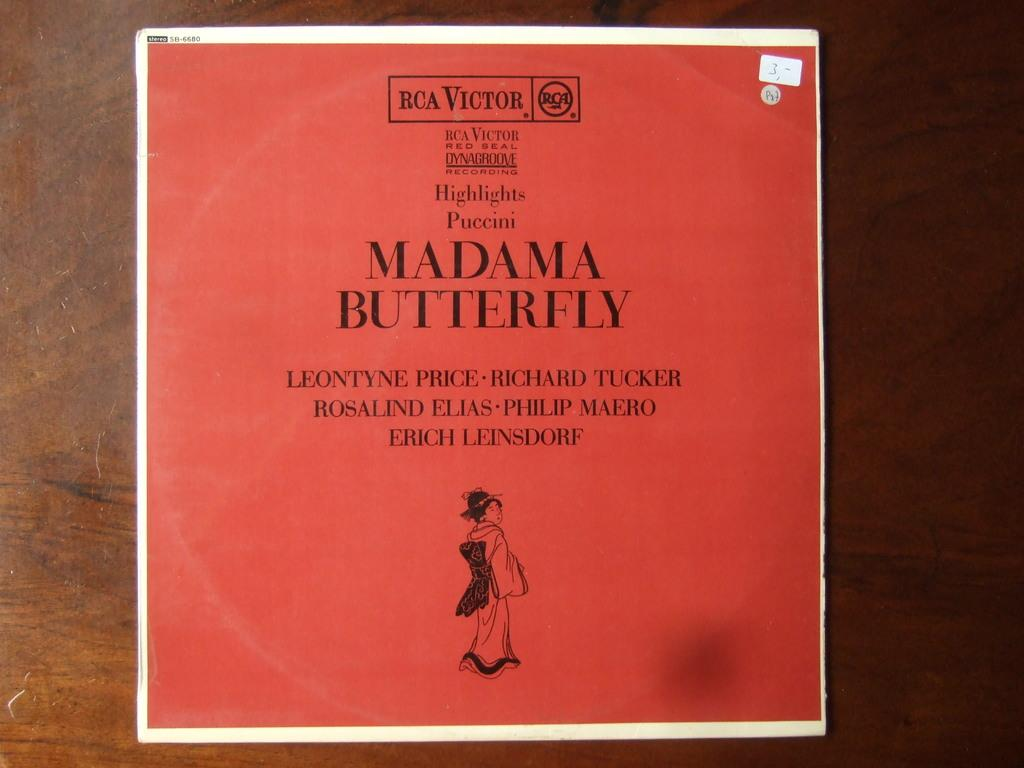<image>
Write a terse but informative summary of the picture. An ablum in red and a white border for Madama Butterfly. 